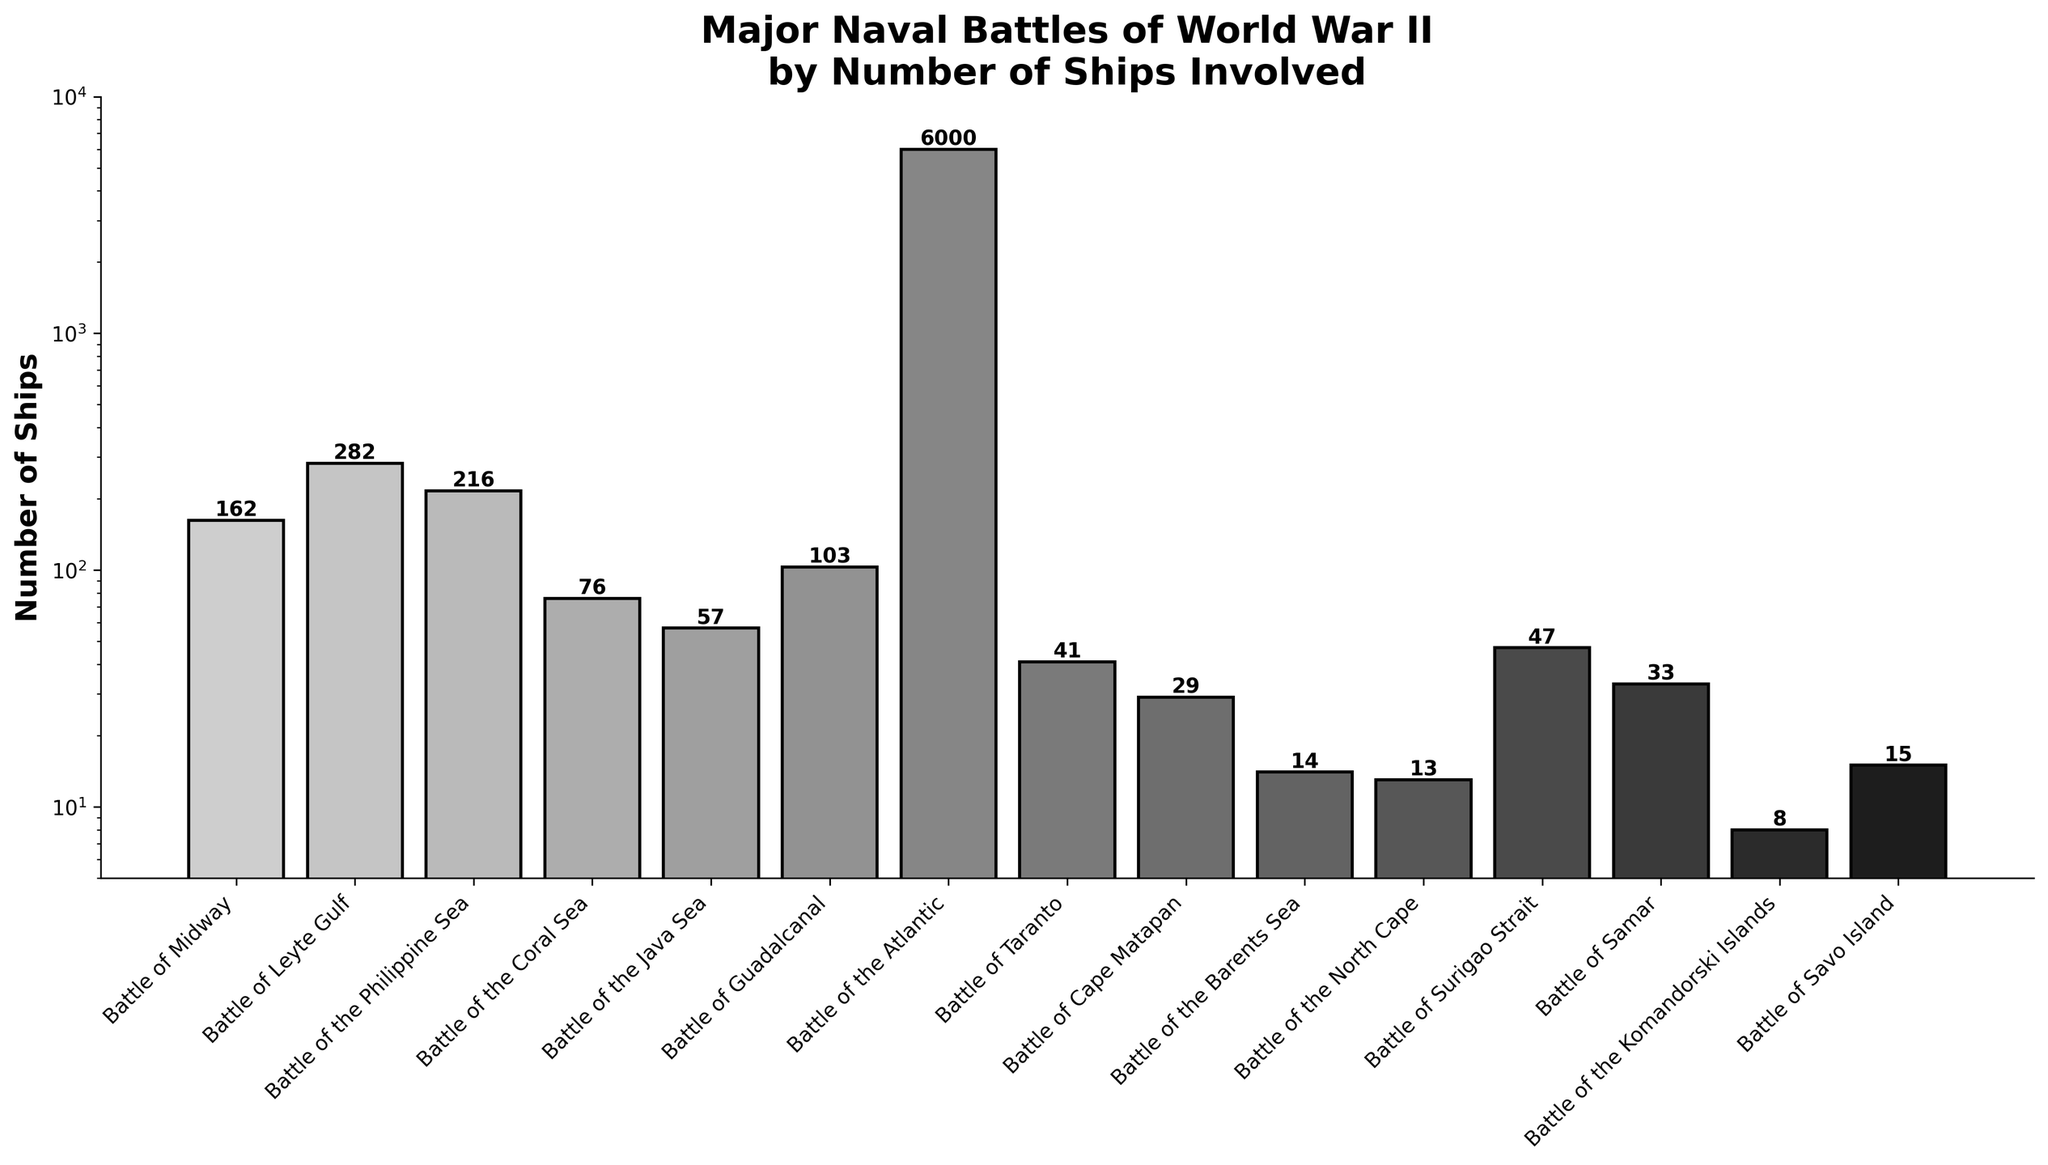Which naval battle had the highest number of ships involved? The bar representing the 'Battle of the Atlantic' is the tallest, indicating it had the highest number of ships.
Answer: Battle of the Atlantic How many more ships were involved in the Battle of Leyte Gulf compared to the Battle of Surigao Strait? The number of ships in the Battle of Leyte Gulf is 282 and in the Battle of Surigao Strait is 47. The difference is 282 - 47.
Answer: 235 What is the average number of ships involved in the Battles of Savo Island, Samar, and Cape Matapan? Sum the number of ships in these battles (15 + 33 + 29) and divide by the number of battles (3). The average is (15 + 33 + 29) / 3.
Answer: 25.67 Does the Battle of the Coral Sea involve more ships than the Battle of Guadalcanal? The bar for the Battle of the Coral Sea indicates 76 ships, while the bar for the Battle of Guadalcanal indicates 103. Since 76 is less than 103, the answer is no.
Answer: No What is the total number of ships involved in the three lowest battles? Identify the three lowest battles: Battle of the North Cape (13), Battle of the Barents Sea (14), and Battle of the Komandorski Islands (8). Sum these numbers: 13 + 14 + 8.
Answer: 35 Which battle is represented by the shortest bar? Identify the shortest bar on the graph, which corresponds to 8 ships involved in the Battle of the Komandorski Islands.
Answer: Battle of the Komandorski Islands Are there more ships involved in the Battle of the Philippine Sea than in the Battle of Midway? The bar for the Battle of the Philippine Sea shows 216 ships, while the bar for the Battle of Midway shows 162 ships. Since 216 is more than 162, the answer is yes.
Answer: Yes What is the difference between the total number of ships involved in the Battle of Java Sea and the Battle of Taranto? The number of ships in the Battle of Java Sea is 57 and in the Battle of Taranto is 41. The difference is 57 - 41.
Answer: 16 